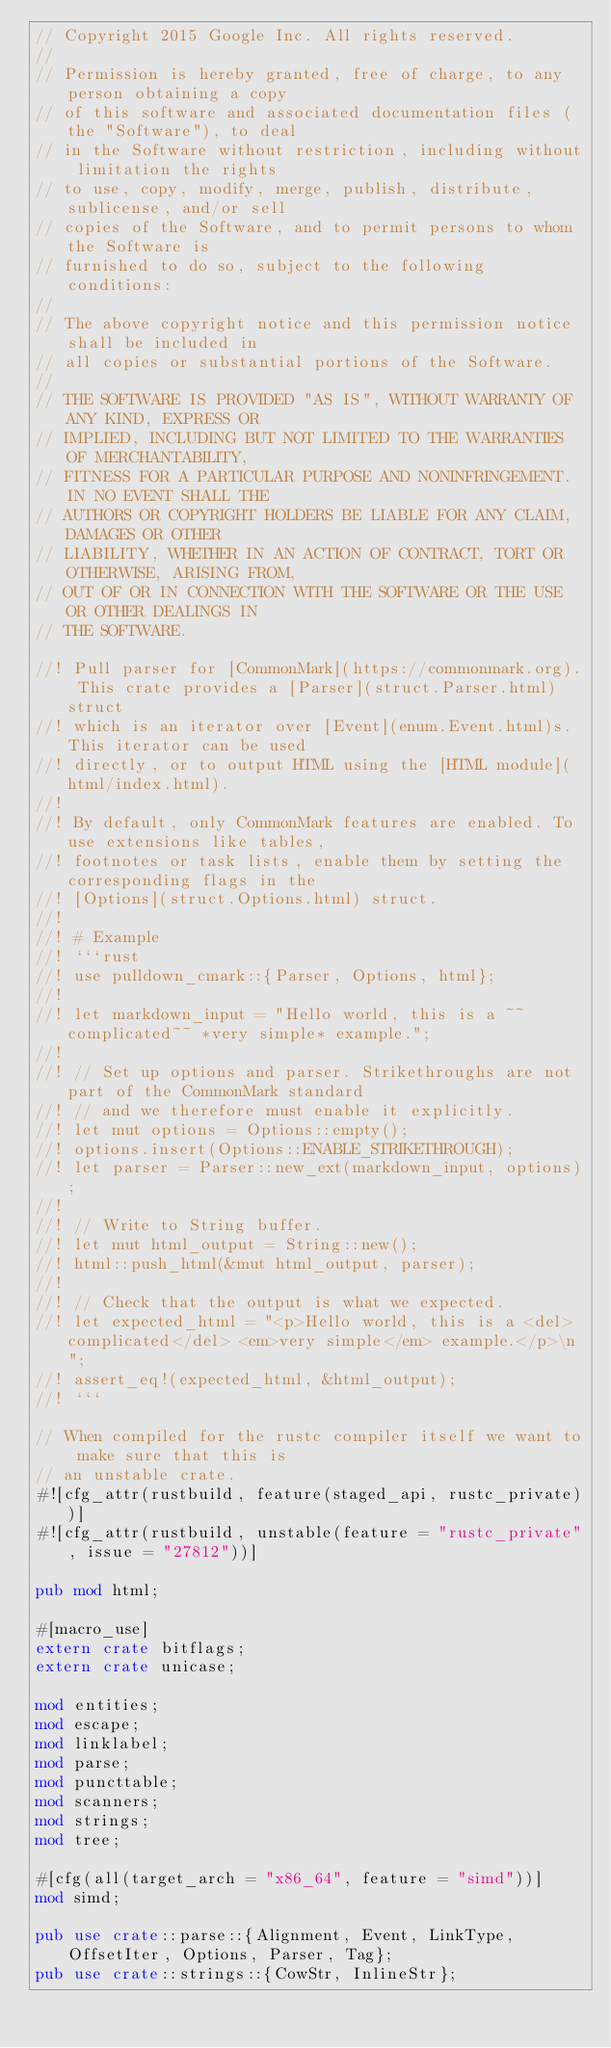Convert code to text. <code><loc_0><loc_0><loc_500><loc_500><_Rust_>// Copyright 2015 Google Inc. All rights reserved.
//
// Permission is hereby granted, free of charge, to any person obtaining a copy
// of this software and associated documentation files (the "Software"), to deal
// in the Software without restriction, including without limitation the rights
// to use, copy, modify, merge, publish, distribute, sublicense, and/or sell
// copies of the Software, and to permit persons to whom the Software is
// furnished to do so, subject to the following conditions:
//
// The above copyright notice and this permission notice shall be included in
// all copies or substantial portions of the Software.
//
// THE SOFTWARE IS PROVIDED "AS IS", WITHOUT WARRANTY OF ANY KIND, EXPRESS OR
// IMPLIED, INCLUDING BUT NOT LIMITED TO THE WARRANTIES OF MERCHANTABILITY,
// FITNESS FOR A PARTICULAR PURPOSE AND NONINFRINGEMENT. IN NO EVENT SHALL THE
// AUTHORS OR COPYRIGHT HOLDERS BE LIABLE FOR ANY CLAIM, DAMAGES OR OTHER
// LIABILITY, WHETHER IN AN ACTION OF CONTRACT, TORT OR OTHERWISE, ARISING FROM,
// OUT OF OR IN CONNECTION WITH THE SOFTWARE OR THE USE OR OTHER DEALINGS IN
// THE SOFTWARE.

//! Pull parser for [CommonMark](https://commonmark.org). This crate provides a [Parser](struct.Parser.html) struct
//! which is an iterator over [Event](enum.Event.html)s. This iterator can be used
//! directly, or to output HTML using the [HTML module](html/index.html).
//!
//! By default, only CommonMark features are enabled. To use extensions like tables,
//! footnotes or task lists, enable them by setting the corresponding flags in the
//! [Options](struct.Options.html) struct.
//!
//! # Example
//! ```rust
//! use pulldown_cmark::{Parser, Options, html};
//!
//! let markdown_input = "Hello world, this is a ~~complicated~~ *very simple* example.";
//!
//! // Set up options and parser. Strikethroughs are not part of the CommonMark standard
//! // and we therefore must enable it explicitly.
//! let mut options = Options::empty();
//! options.insert(Options::ENABLE_STRIKETHROUGH);
//! let parser = Parser::new_ext(markdown_input, options);
//!
//! // Write to String buffer.
//! let mut html_output = String::new();
//! html::push_html(&mut html_output, parser);
//!
//! // Check that the output is what we expected.
//! let expected_html = "<p>Hello world, this is a <del>complicated</del> <em>very simple</em> example.</p>\n";
//! assert_eq!(expected_html, &html_output);
//! ```

// When compiled for the rustc compiler itself we want to make sure that this is
// an unstable crate.
#![cfg_attr(rustbuild, feature(staged_api, rustc_private))]
#![cfg_attr(rustbuild, unstable(feature = "rustc_private", issue = "27812"))]

pub mod html;

#[macro_use]
extern crate bitflags;
extern crate unicase;

mod entities;
mod escape;
mod linklabel;
mod parse;
mod puncttable;
mod scanners;
mod strings;
mod tree;

#[cfg(all(target_arch = "x86_64", feature = "simd"))]
mod simd;

pub use crate::parse::{Alignment, Event, LinkType, OffsetIter, Options, Parser, Tag};
pub use crate::strings::{CowStr, InlineStr};
</code> 